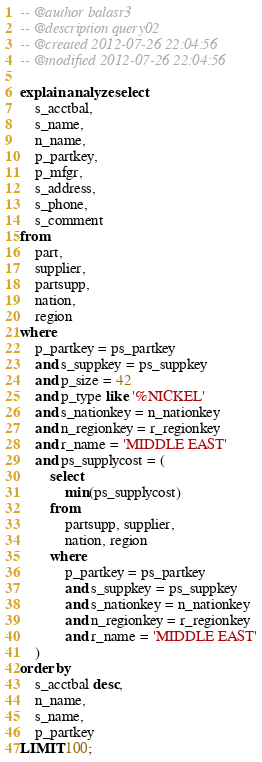<code> <loc_0><loc_0><loc_500><loc_500><_SQL_>-- @author balasr3
-- @description query02
-- @created 2012-07-26 22:04:56
-- @modified 2012-07-26 22:04:56

explain analyze select
	s_acctbal,
	s_name,
	n_name,
	p_partkey,
	p_mfgr,
	s_address,
	s_phone,
	s_comment
from
	part,
	supplier,
	partsupp,
	nation,
	region
where
	p_partkey = ps_partkey
	and s_suppkey = ps_suppkey
	and p_size = 42
	and p_type like '%NICKEL'
	and s_nationkey = n_nationkey
	and n_regionkey = r_regionkey
	and r_name = 'MIDDLE EAST'
	and ps_supplycost = (
		select
			min(ps_supplycost)
		from
			partsupp, supplier,
			nation, region
		where
			p_partkey = ps_partkey
			and s_suppkey = ps_suppkey
			and s_nationkey = n_nationkey
			and n_regionkey = r_regionkey
			and r_name = 'MIDDLE EAST'
	)
order by
	s_acctbal desc,
	n_name,
	s_name,
	p_partkey
LIMIT 100;
</code> 